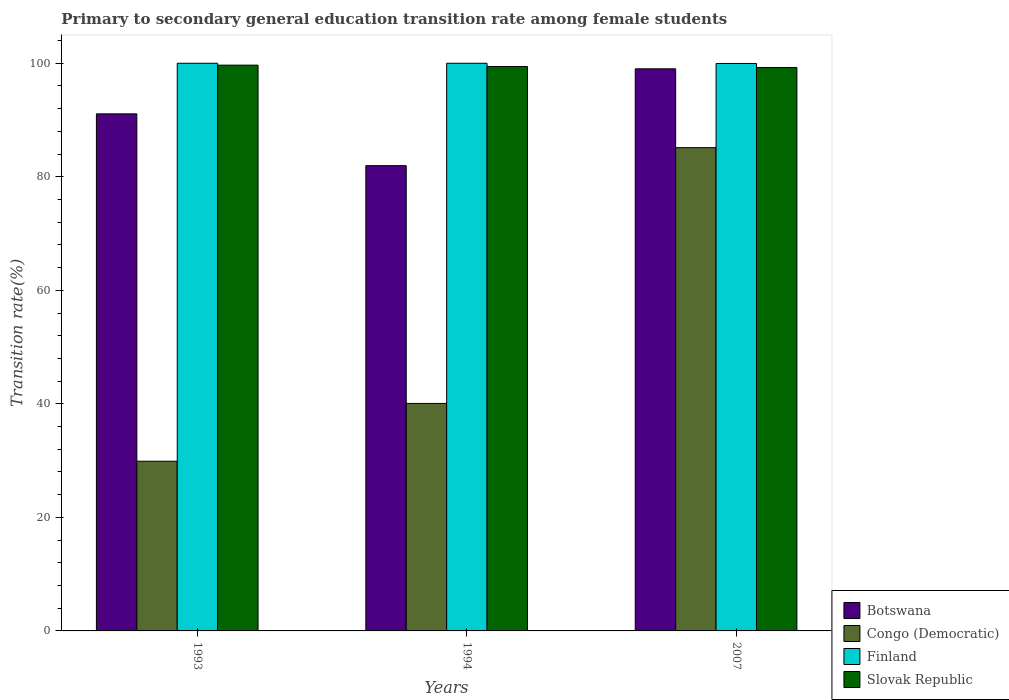How many different coloured bars are there?
Offer a very short reply. 4. How many groups of bars are there?
Keep it short and to the point. 3. Are the number of bars on each tick of the X-axis equal?
Keep it short and to the point. Yes. How many bars are there on the 2nd tick from the right?
Provide a succinct answer. 4. What is the transition rate in Slovak Republic in 2007?
Your answer should be compact. 99.25. Across all years, what is the maximum transition rate in Congo (Democratic)?
Provide a short and direct response. 85.13. Across all years, what is the minimum transition rate in Slovak Republic?
Your response must be concise. 99.25. What is the total transition rate in Finland in the graph?
Your answer should be compact. 299.96. What is the difference between the transition rate in Slovak Republic in 1993 and that in 1994?
Offer a terse response. 0.24. What is the difference between the transition rate in Slovak Republic in 2007 and the transition rate in Congo (Democratic) in 1994?
Keep it short and to the point. 59.17. What is the average transition rate in Slovak Republic per year?
Make the answer very short. 99.45. In the year 1993, what is the difference between the transition rate in Botswana and transition rate in Slovak Republic?
Provide a short and direct response. -8.58. What is the ratio of the transition rate in Finland in 1994 to that in 2007?
Keep it short and to the point. 1. Is the transition rate in Finland in 1994 less than that in 2007?
Keep it short and to the point. No. Is the difference between the transition rate in Botswana in 1993 and 2007 greater than the difference between the transition rate in Slovak Republic in 1993 and 2007?
Offer a very short reply. No. What is the difference between the highest and the second highest transition rate in Slovak Republic?
Your answer should be very brief. 0.24. What is the difference between the highest and the lowest transition rate in Congo (Democratic)?
Give a very brief answer. 55.24. Is it the case that in every year, the sum of the transition rate in Slovak Republic and transition rate in Finland is greater than the sum of transition rate in Congo (Democratic) and transition rate in Botswana?
Make the answer very short. Yes. What does the 4th bar from the right in 2007 represents?
Ensure brevity in your answer.  Botswana. Is it the case that in every year, the sum of the transition rate in Finland and transition rate in Congo (Democratic) is greater than the transition rate in Botswana?
Provide a short and direct response. Yes. How many bars are there?
Provide a short and direct response. 12. Are all the bars in the graph horizontal?
Provide a succinct answer. No. Does the graph contain any zero values?
Your answer should be compact. No. Does the graph contain grids?
Provide a succinct answer. No. How many legend labels are there?
Give a very brief answer. 4. What is the title of the graph?
Ensure brevity in your answer.  Primary to secondary general education transition rate among female students. What is the label or title of the Y-axis?
Your answer should be compact. Transition rate(%). What is the Transition rate(%) of Botswana in 1993?
Give a very brief answer. 91.09. What is the Transition rate(%) in Congo (Democratic) in 1993?
Keep it short and to the point. 29.89. What is the Transition rate(%) of Slovak Republic in 1993?
Your answer should be very brief. 99.67. What is the Transition rate(%) in Botswana in 1994?
Give a very brief answer. 81.96. What is the Transition rate(%) in Congo (Democratic) in 1994?
Your answer should be compact. 40.08. What is the Transition rate(%) in Slovak Republic in 1994?
Your answer should be very brief. 99.42. What is the Transition rate(%) in Botswana in 2007?
Provide a short and direct response. 99.02. What is the Transition rate(%) of Congo (Democratic) in 2007?
Make the answer very short. 85.13. What is the Transition rate(%) of Finland in 2007?
Make the answer very short. 99.96. What is the Transition rate(%) in Slovak Republic in 2007?
Provide a short and direct response. 99.25. Across all years, what is the maximum Transition rate(%) of Botswana?
Ensure brevity in your answer.  99.02. Across all years, what is the maximum Transition rate(%) of Congo (Democratic)?
Your answer should be very brief. 85.13. Across all years, what is the maximum Transition rate(%) in Slovak Republic?
Ensure brevity in your answer.  99.67. Across all years, what is the minimum Transition rate(%) of Botswana?
Provide a succinct answer. 81.96. Across all years, what is the minimum Transition rate(%) in Congo (Democratic)?
Your response must be concise. 29.89. Across all years, what is the minimum Transition rate(%) of Finland?
Offer a very short reply. 99.96. Across all years, what is the minimum Transition rate(%) in Slovak Republic?
Provide a short and direct response. 99.25. What is the total Transition rate(%) in Botswana in the graph?
Your answer should be very brief. 272.07. What is the total Transition rate(%) in Congo (Democratic) in the graph?
Offer a terse response. 155.1. What is the total Transition rate(%) in Finland in the graph?
Offer a terse response. 299.96. What is the total Transition rate(%) in Slovak Republic in the graph?
Provide a succinct answer. 298.34. What is the difference between the Transition rate(%) in Botswana in 1993 and that in 1994?
Make the answer very short. 9.12. What is the difference between the Transition rate(%) in Congo (Democratic) in 1993 and that in 1994?
Provide a short and direct response. -10.18. What is the difference between the Transition rate(%) of Slovak Republic in 1993 and that in 1994?
Your answer should be compact. 0.24. What is the difference between the Transition rate(%) of Botswana in 1993 and that in 2007?
Ensure brevity in your answer.  -7.94. What is the difference between the Transition rate(%) in Congo (Democratic) in 1993 and that in 2007?
Your response must be concise. -55.24. What is the difference between the Transition rate(%) in Finland in 1993 and that in 2007?
Offer a terse response. 0.04. What is the difference between the Transition rate(%) of Slovak Republic in 1993 and that in 2007?
Give a very brief answer. 0.42. What is the difference between the Transition rate(%) in Botswana in 1994 and that in 2007?
Offer a terse response. -17.06. What is the difference between the Transition rate(%) of Congo (Democratic) in 1994 and that in 2007?
Your answer should be very brief. -45.05. What is the difference between the Transition rate(%) in Finland in 1994 and that in 2007?
Make the answer very short. 0.04. What is the difference between the Transition rate(%) in Slovak Republic in 1994 and that in 2007?
Your answer should be compact. 0.18. What is the difference between the Transition rate(%) of Botswana in 1993 and the Transition rate(%) of Congo (Democratic) in 1994?
Offer a very short reply. 51.01. What is the difference between the Transition rate(%) of Botswana in 1993 and the Transition rate(%) of Finland in 1994?
Offer a very short reply. -8.91. What is the difference between the Transition rate(%) in Botswana in 1993 and the Transition rate(%) in Slovak Republic in 1994?
Make the answer very short. -8.34. What is the difference between the Transition rate(%) in Congo (Democratic) in 1993 and the Transition rate(%) in Finland in 1994?
Your response must be concise. -70.11. What is the difference between the Transition rate(%) in Congo (Democratic) in 1993 and the Transition rate(%) in Slovak Republic in 1994?
Keep it short and to the point. -69.53. What is the difference between the Transition rate(%) of Finland in 1993 and the Transition rate(%) of Slovak Republic in 1994?
Ensure brevity in your answer.  0.58. What is the difference between the Transition rate(%) in Botswana in 1993 and the Transition rate(%) in Congo (Democratic) in 2007?
Ensure brevity in your answer.  5.96. What is the difference between the Transition rate(%) of Botswana in 1993 and the Transition rate(%) of Finland in 2007?
Your answer should be compact. -8.88. What is the difference between the Transition rate(%) of Botswana in 1993 and the Transition rate(%) of Slovak Republic in 2007?
Make the answer very short. -8.16. What is the difference between the Transition rate(%) of Congo (Democratic) in 1993 and the Transition rate(%) of Finland in 2007?
Offer a terse response. -70.07. What is the difference between the Transition rate(%) in Congo (Democratic) in 1993 and the Transition rate(%) in Slovak Republic in 2007?
Your response must be concise. -69.35. What is the difference between the Transition rate(%) in Finland in 1993 and the Transition rate(%) in Slovak Republic in 2007?
Your answer should be very brief. 0.75. What is the difference between the Transition rate(%) in Botswana in 1994 and the Transition rate(%) in Congo (Democratic) in 2007?
Your response must be concise. -3.17. What is the difference between the Transition rate(%) of Botswana in 1994 and the Transition rate(%) of Finland in 2007?
Your answer should be very brief. -18. What is the difference between the Transition rate(%) in Botswana in 1994 and the Transition rate(%) in Slovak Republic in 2007?
Give a very brief answer. -17.29. What is the difference between the Transition rate(%) of Congo (Democratic) in 1994 and the Transition rate(%) of Finland in 2007?
Make the answer very short. -59.89. What is the difference between the Transition rate(%) of Congo (Democratic) in 1994 and the Transition rate(%) of Slovak Republic in 2007?
Provide a succinct answer. -59.17. What is the difference between the Transition rate(%) in Finland in 1994 and the Transition rate(%) in Slovak Republic in 2007?
Keep it short and to the point. 0.75. What is the average Transition rate(%) of Botswana per year?
Make the answer very short. 90.69. What is the average Transition rate(%) of Congo (Democratic) per year?
Offer a very short reply. 51.7. What is the average Transition rate(%) in Finland per year?
Ensure brevity in your answer.  99.99. What is the average Transition rate(%) in Slovak Republic per year?
Provide a succinct answer. 99.45. In the year 1993, what is the difference between the Transition rate(%) in Botswana and Transition rate(%) in Congo (Democratic)?
Provide a short and direct response. 61.19. In the year 1993, what is the difference between the Transition rate(%) of Botswana and Transition rate(%) of Finland?
Your answer should be compact. -8.91. In the year 1993, what is the difference between the Transition rate(%) in Botswana and Transition rate(%) in Slovak Republic?
Ensure brevity in your answer.  -8.58. In the year 1993, what is the difference between the Transition rate(%) in Congo (Democratic) and Transition rate(%) in Finland?
Your answer should be very brief. -70.11. In the year 1993, what is the difference between the Transition rate(%) in Congo (Democratic) and Transition rate(%) in Slovak Republic?
Your answer should be compact. -69.77. In the year 1993, what is the difference between the Transition rate(%) of Finland and Transition rate(%) of Slovak Republic?
Offer a very short reply. 0.33. In the year 1994, what is the difference between the Transition rate(%) of Botswana and Transition rate(%) of Congo (Democratic)?
Ensure brevity in your answer.  41.89. In the year 1994, what is the difference between the Transition rate(%) of Botswana and Transition rate(%) of Finland?
Provide a succinct answer. -18.04. In the year 1994, what is the difference between the Transition rate(%) of Botswana and Transition rate(%) of Slovak Republic?
Your answer should be very brief. -17.46. In the year 1994, what is the difference between the Transition rate(%) in Congo (Democratic) and Transition rate(%) in Finland?
Offer a terse response. -59.92. In the year 1994, what is the difference between the Transition rate(%) in Congo (Democratic) and Transition rate(%) in Slovak Republic?
Provide a succinct answer. -59.35. In the year 1994, what is the difference between the Transition rate(%) in Finland and Transition rate(%) in Slovak Republic?
Offer a terse response. 0.58. In the year 2007, what is the difference between the Transition rate(%) of Botswana and Transition rate(%) of Congo (Democratic)?
Ensure brevity in your answer.  13.89. In the year 2007, what is the difference between the Transition rate(%) of Botswana and Transition rate(%) of Finland?
Your answer should be very brief. -0.94. In the year 2007, what is the difference between the Transition rate(%) in Botswana and Transition rate(%) in Slovak Republic?
Your answer should be compact. -0.23. In the year 2007, what is the difference between the Transition rate(%) in Congo (Democratic) and Transition rate(%) in Finland?
Offer a terse response. -14.83. In the year 2007, what is the difference between the Transition rate(%) in Congo (Democratic) and Transition rate(%) in Slovak Republic?
Keep it short and to the point. -14.12. In the year 2007, what is the difference between the Transition rate(%) of Finland and Transition rate(%) of Slovak Republic?
Your answer should be very brief. 0.71. What is the ratio of the Transition rate(%) of Botswana in 1993 to that in 1994?
Provide a short and direct response. 1.11. What is the ratio of the Transition rate(%) of Congo (Democratic) in 1993 to that in 1994?
Keep it short and to the point. 0.75. What is the ratio of the Transition rate(%) of Finland in 1993 to that in 1994?
Ensure brevity in your answer.  1. What is the ratio of the Transition rate(%) in Botswana in 1993 to that in 2007?
Give a very brief answer. 0.92. What is the ratio of the Transition rate(%) in Congo (Democratic) in 1993 to that in 2007?
Your response must be concise. 0.35. What is the ratio of the Transition rate(%) of Slovak Republic in 1993 to that in 2007?
Your answer should be compact. 1. What is the ratio of the Transition rate(%) in Botswana in 1994 to that in 2007?
Your answer should be compact. 0.83. What is the ratio of the Transition rate(%) in Congo (Democratic) in 1994 to that in 2007?
Give a very brief answer. 0.47. What is the difference between the highest and the second highest Transition rate(%) in Botswana?
Your response must be concise. 7.94. What is the difference between the highest and the second highest Transition rate(%) of Congo (Democratic)?
Your answer should be compact. 45.05. What is the difference between the highest and the second highest Transition rate(%) in Finland?
Offer a terse response. 0. What is the difference between the highest and the second highest Transition rate(%) of Slovak Republic?
Give a very brief answer. 0.24. What is the difference between the highest and the lowest Transition rate(%) of Botswana?
Your answer should be very brief. 17.06. What is the difference between the highest and the lowest Transition rate(%) of Congo (Democratic)?
Give a very brief answer. 55.24. What is the difference between the highest and the lowest Transition rate(%) of Finland?
Provide a short and direct response. 0.04. What is the difference between the highest and the lowest Transition rate(%) of Slovak Republic?
Make the answer very short. 0.42. 